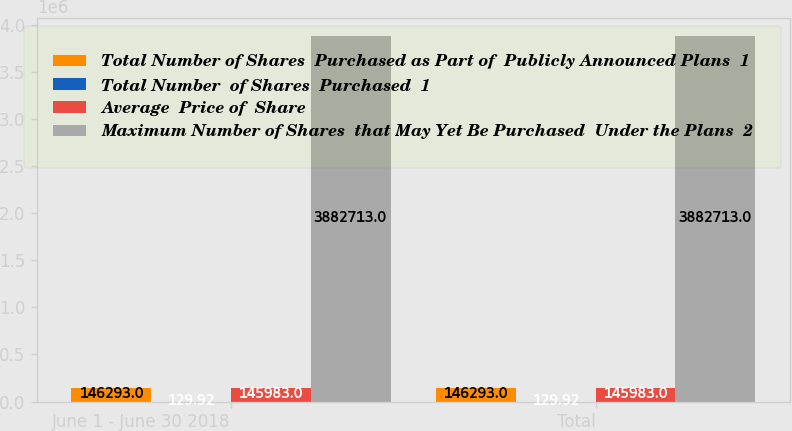Convert chart to OTSL. <chart><loc_0><loc_0><loc_500><loc_500><stacked_bar_chart><ecel><fcel>June 1 - June 30 2018<fcel>Total<nl><fcel>Total Number of Shares  Purchased as Part of  Publicly Announced Plans  1<fcel>146293<fcel>146293<nl><fcel>Total Number  of Shares  Purchased  1<fcel>129.92<fcel>129.92<nl><fcel>Average  Price of  Share<fcel>145983<fcel>145983<nl><fcel>Maximum Number of Shares  that May Yet Be Purchased  Under the Plans  2<fcel>3.88271e+06<fcel>3.88271e+06<nl></chart> 